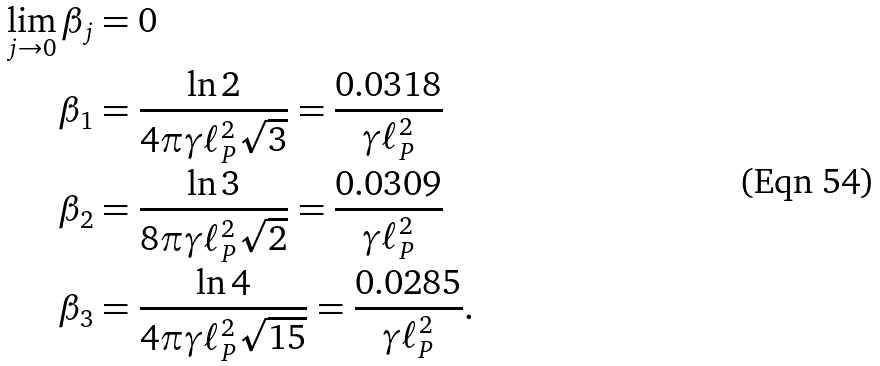<formula> <loc_0><loc_0><loc_500><loc_500>\lim _ { j \rightarrow 0 } \beta _ { j } & = 0 \\ \beta _ { 1 } & = \frac { \ln 2 } { 4 \pi \gamma \ell _ { P } ^ { 2 } \sqrt { 3 } } = \frac { 0 . 0 3 1 8 } { \gamma \ell _ { P } ^ { 2 } } \\ \beta _ { 2 } & = \frac { \ln 3 } { 8 \pi \gamma \ell _ { P } ^ { 2 } \sqrt { 2 } } = \frac { 0 . 0 3 0 9 } { \gamma \ell _ { P } ^ { 2 } } \\ \beta _ { 3 } & = \frac { \ln 4 } { 4 \pi \gamma \ell _ { P } ^ { 2 } \sqrt { 1 5 } } = \frac { 0 . 0 2 8 5 } { \gamma \ell _ { P } ^ { 2 } } .</formula> 